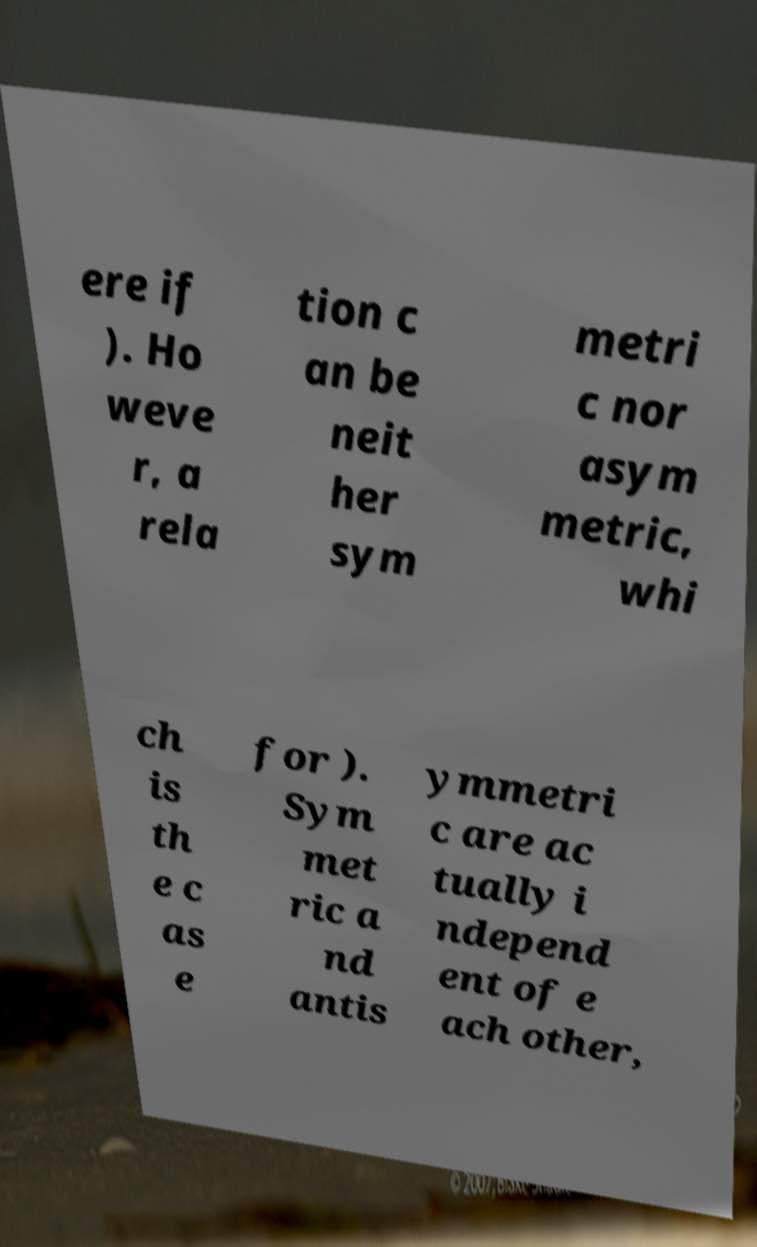There's text embedded in this image that I need extracted. Can you transcribe it verbatim? ere if ). Ho weve r, a rela tion c an be neit her sym metri c nor asym metric, whi ch is th e c as e for ). Sym met ric a nd antis ymmetri c are ac tually i ndepend ent of e ach other, 